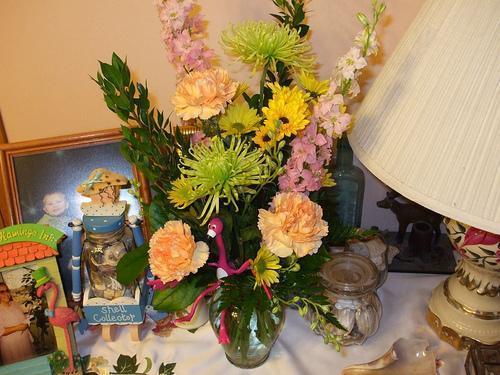How many vases are visible?
Give a very brief answer. 2. 